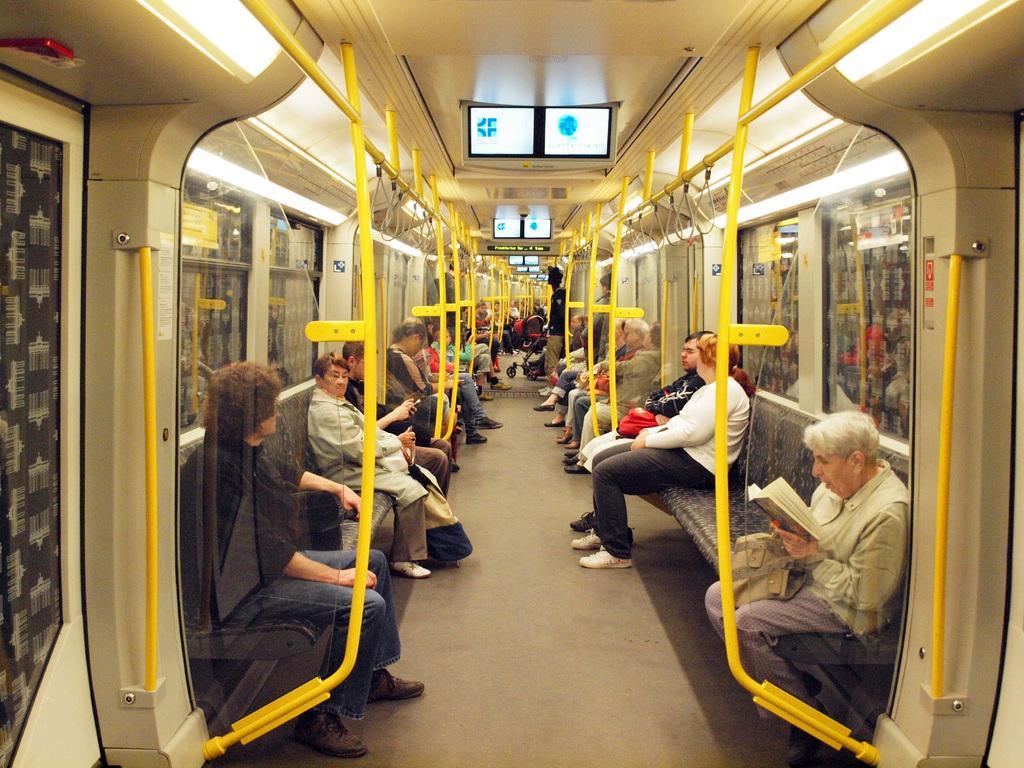Please provide a concise description of this image. This is inside a train. There are handles, glass windows. Many people are siting on seats. One lady is holding a book. Also there are screens. 